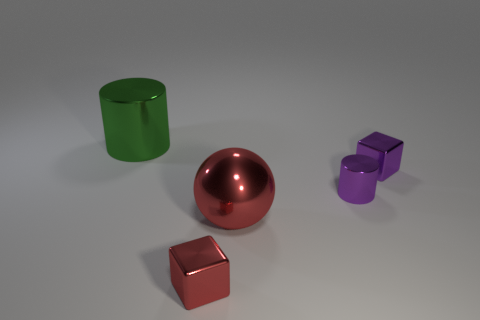Add 2 gray metallic balls. How many objects exist? 7 Subtract all cylinders. How many objects are left? 3 Subtract 1 cubes. How many cubes are left? 1 Subtract all cyan cylinders. Subtract all brown cubes. How many cylinders are left? 2 Subtract all gray balls. How many brown cylinders are left? 0 Subtract all large gray cylinders. Subtract all large green metallic cylinders. How many objects are left? 4 Add 3 big cylinders. How many big cylinders are left? 4 Add 5 small gray rubber things. How many small gray rubber things exist? 5 Subtract 0 brown cubes. How many objects are left? 5 